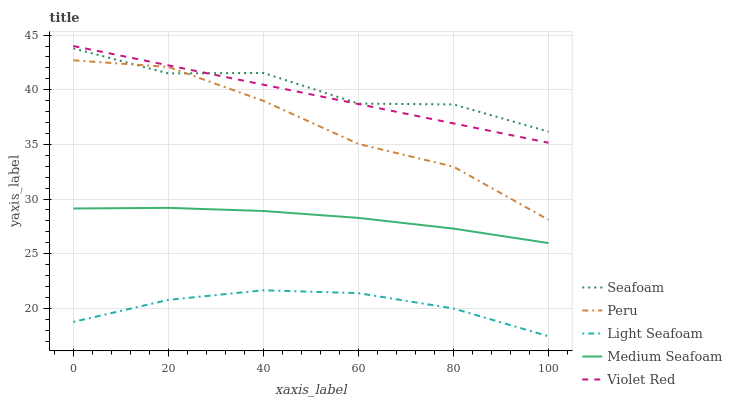Does Light Seafoam have the minimum area under the curve?
Answer yes or no. Yes. Does Seafoam have the maximum area under the curve?
Answer yes or no. Yes. Does Seafoam have the minimum area under the curve?
Answer yes or no. No. Does Light Seafoam have the maximum area under the curve?
Answer yes or no. No. Is Violet Red the smoothest?
Answer yes or no. Yes. Is Seafoam the roughest?
Answer yes or no. Yes. Is Light Seafoam the smoothest?
Answer yes or no. No. Is Light Seafoam the roughest?
Answer yes or no. No. Does Light Seafoam have the lowest value?
Answer yes or no. Yes. Does Seafoam have the lowest value?
Answer yes or no. No. Does Violet Red have the highest value?
Answer yes or no. Yes. Does Seafoam have the highest value?
Answer yes or no. No. Is Medium Seafoam less than Seafoam?
Answer yes or no. Yes. Is Violet Red greater than Medium Seafoam?
Answer yes or no. Yes. Does Seafoam intersect Peru?
Answer yes or no. Yes. Is Seafoam less than Peru?
Answer yes or no. No. Is Seafoam greater than Peru?
Answer yes or no. No. Does Medium Seafoam intersect Seafoam?
Answer yes or no. No. 